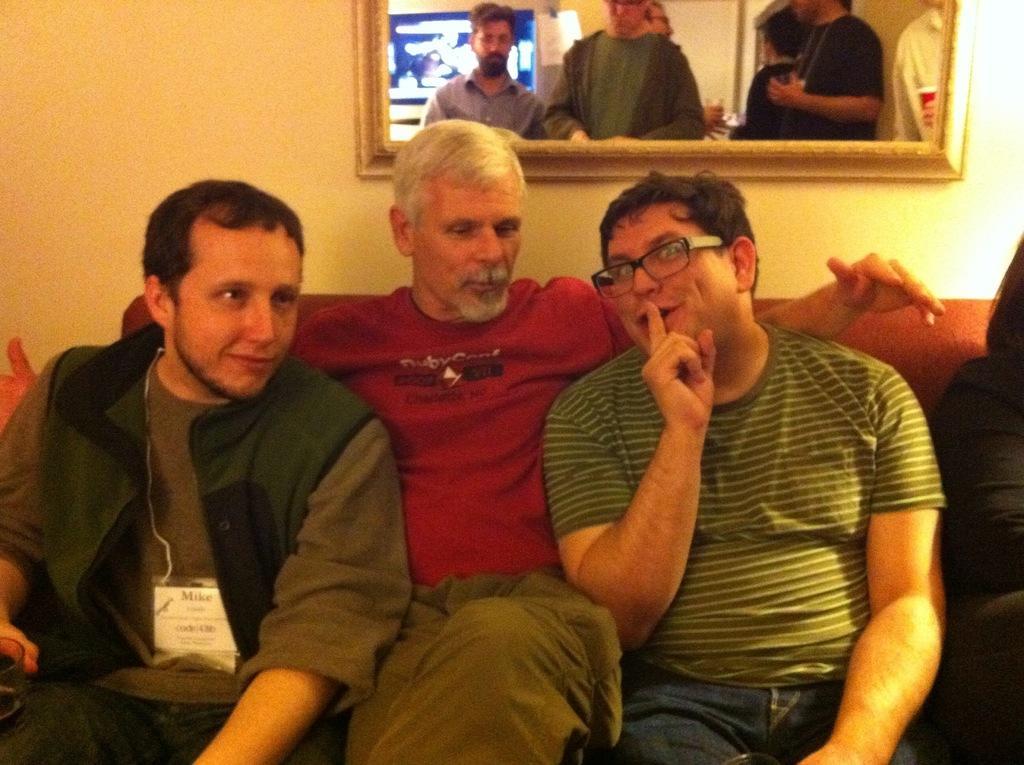Can you describe this image briefly? In this image I can see three people are sitting on a sofa. Among them this man is wearing spectacles. In the background I can see people and a wall. 